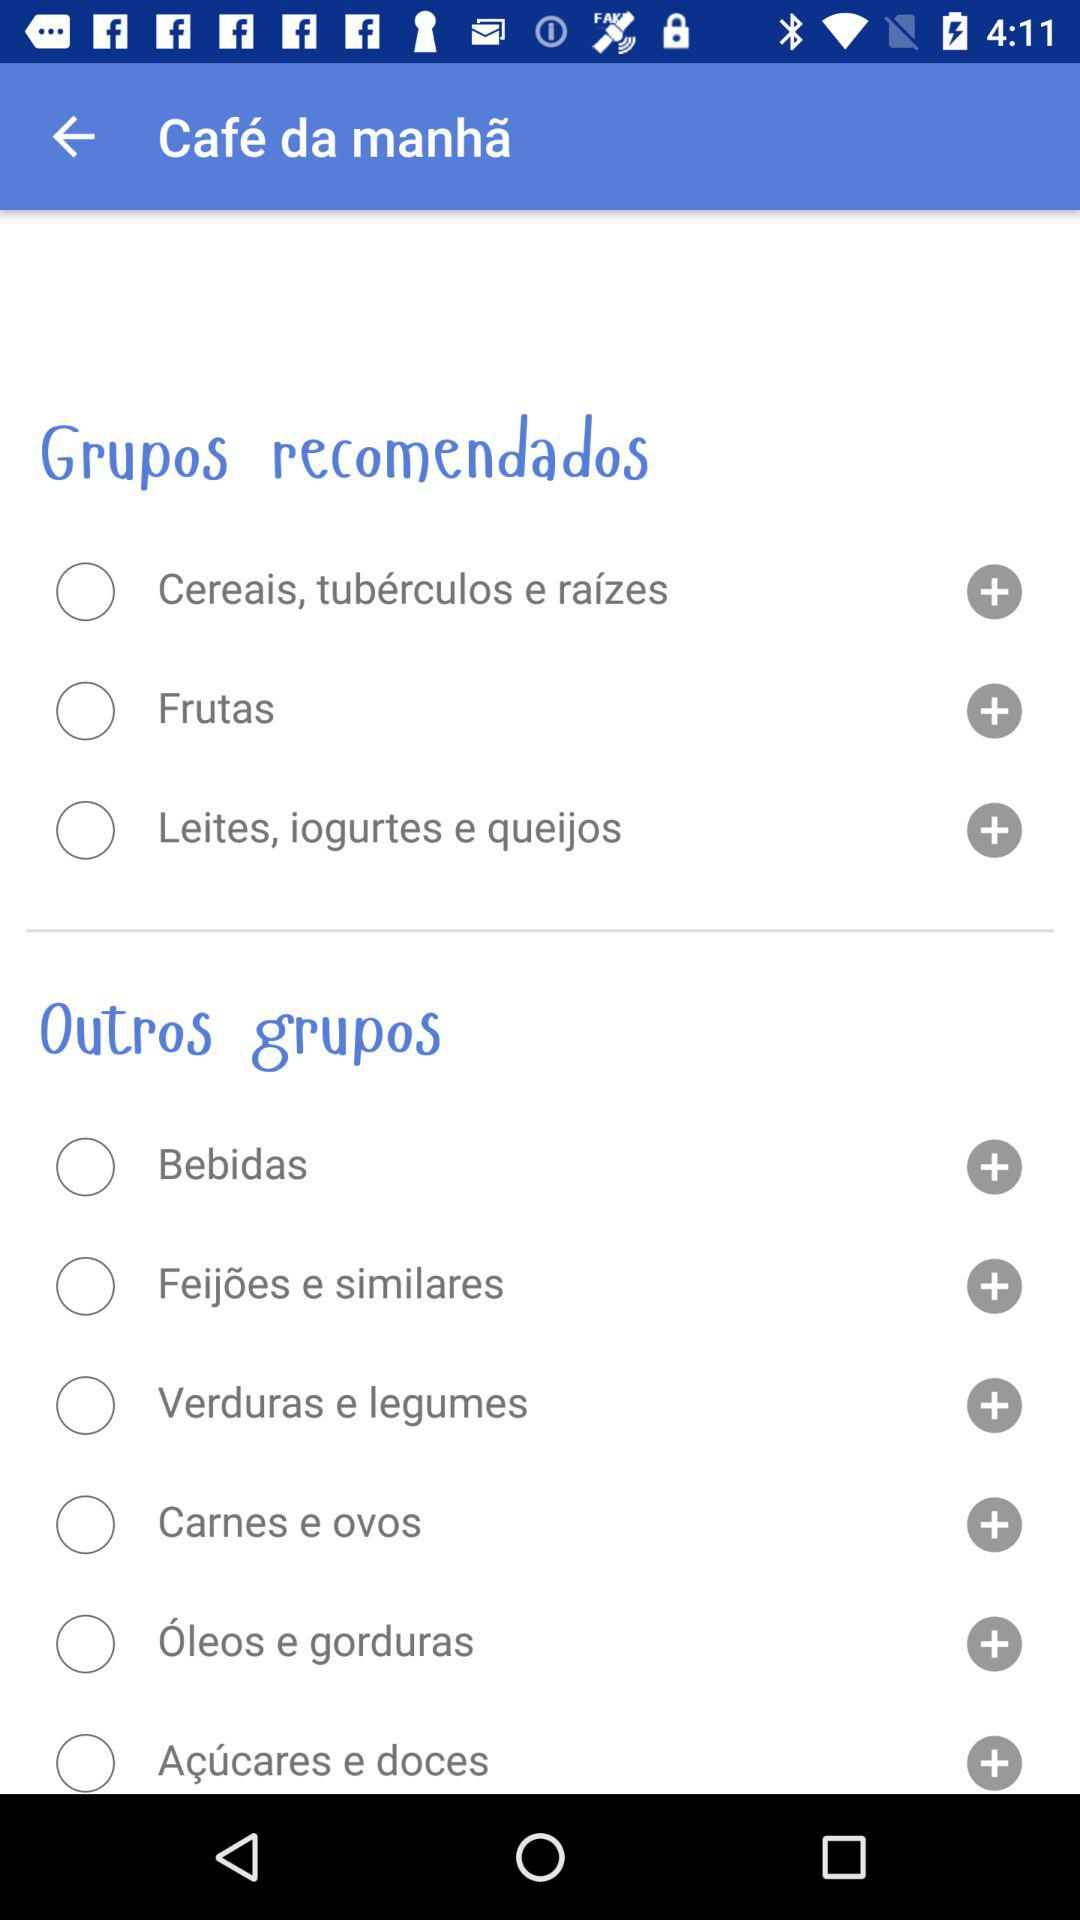How many groups are there in the 'Outros grupos' section?
Answer the question using a single word or phrase. 6 